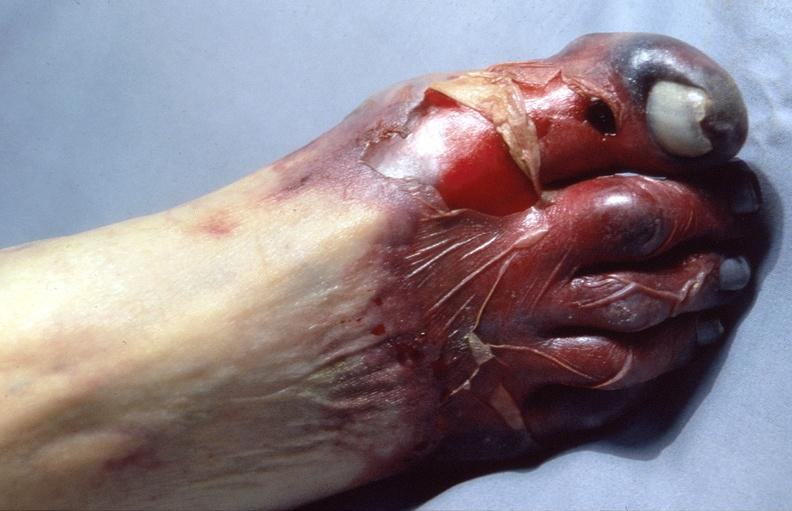what does this image show?
Answer the question using a single word or phrase. Skin ulceration and necrosis 